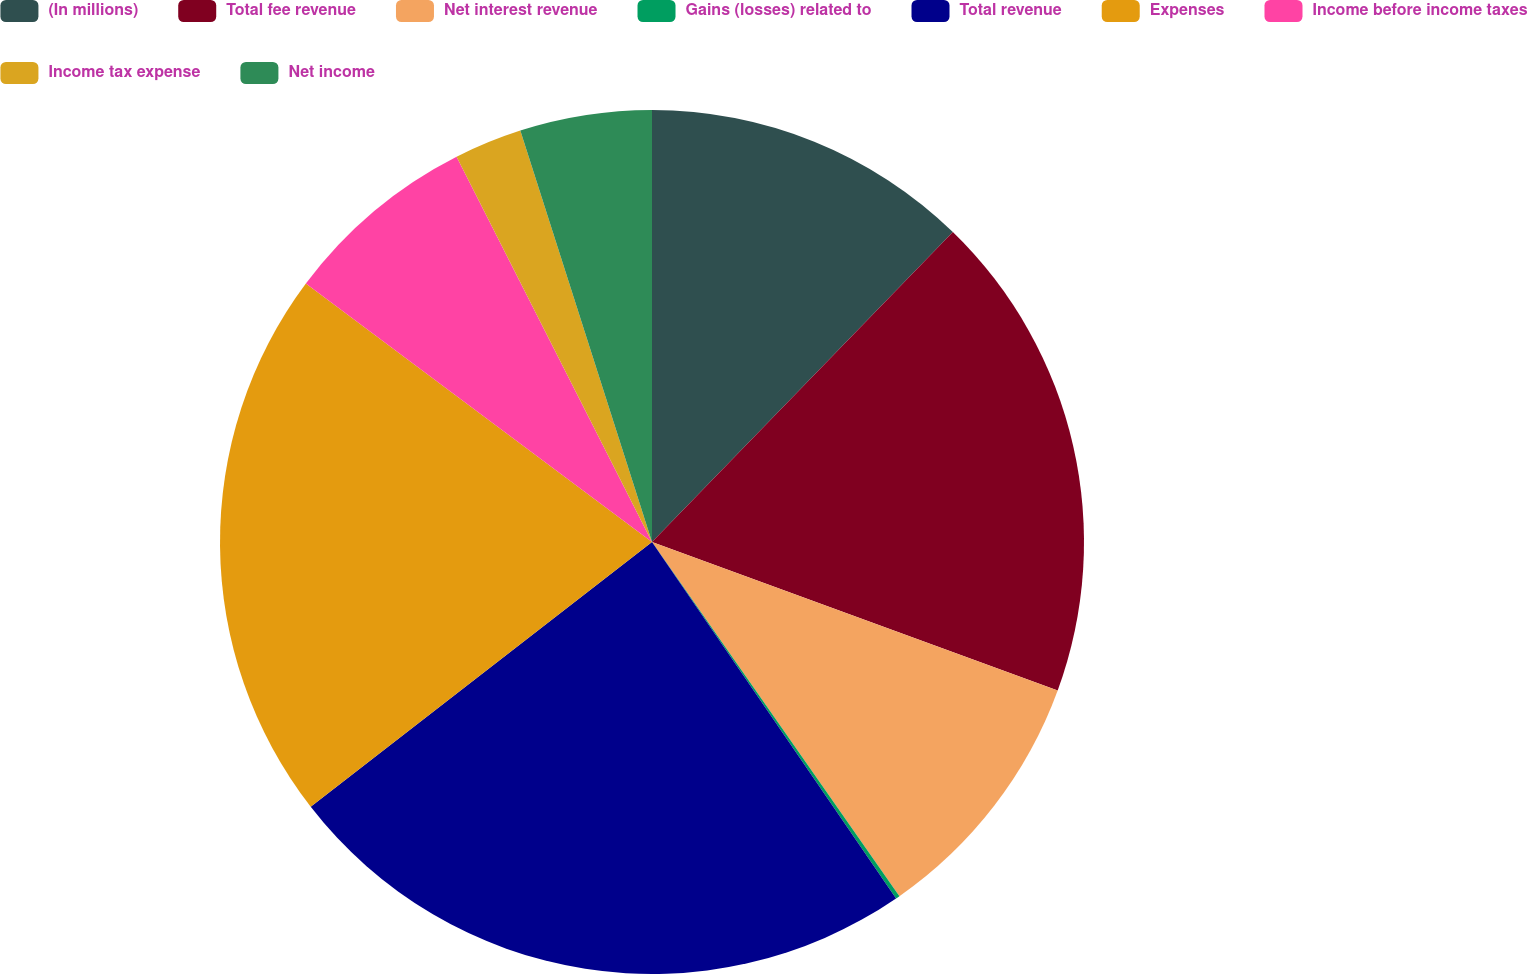<chart> <loc_0><loc_0><loc_500><loc_500><pie_chart><fcel>(In millions)<fcel>Total fee revenue<fcel>Net interest revenue<fcel>Gains (losses) related to<fcel>Total revenue<fcel>Expenses<fcel>Income before income taxes<fcel>Income tax expense<fcel>Net income<nl><fcel>12.26%<fcel>18.32%<fcel>9.71%<fcel>0.15%<fcel>24.05%<fcel>20.71%<fcel>7.32%<fcel>2.54%<fcel>4.93%<nl></chart> 